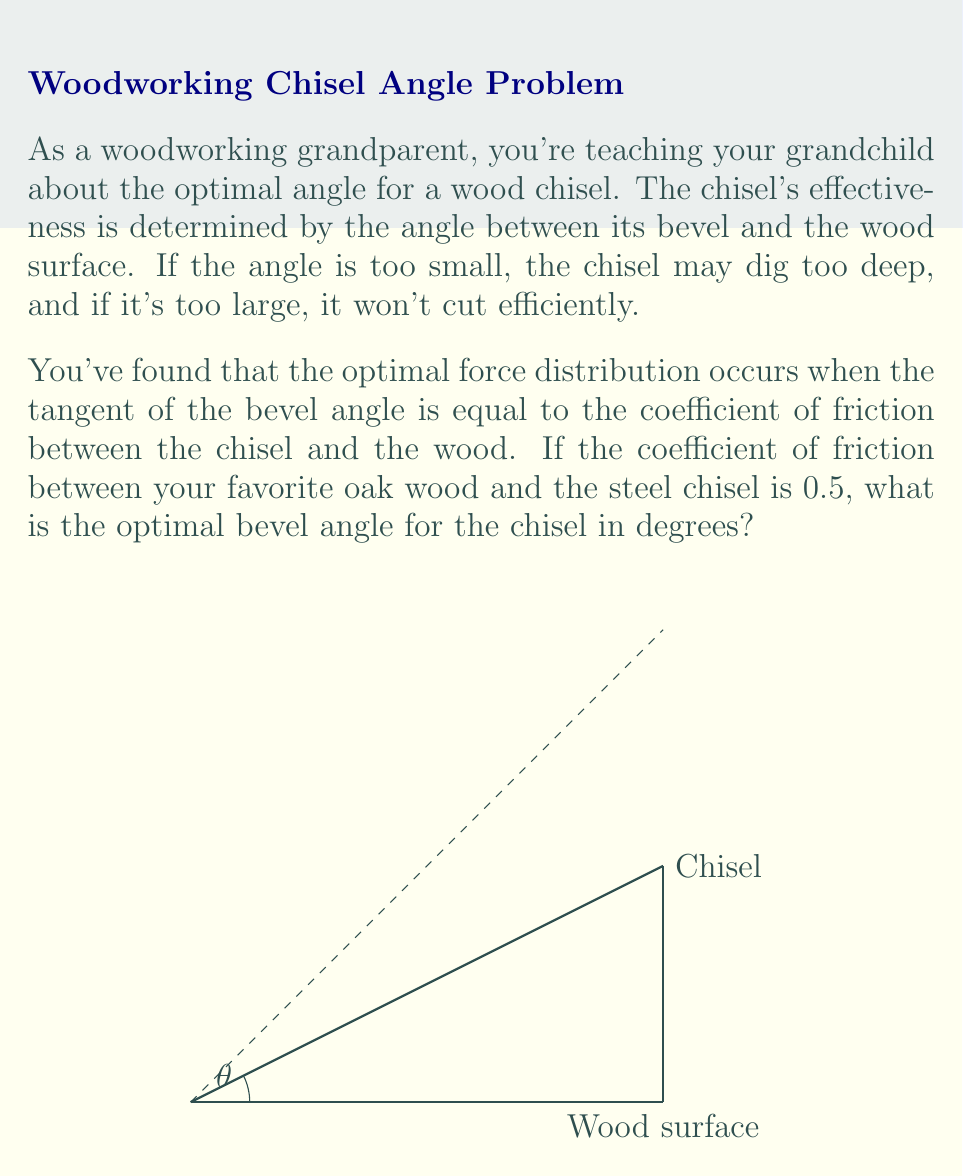Can you answer this question? Let's approach this step-by-step:

1) We're given that the optimal angle occurs when:

   $$\tan(\theta) = \mu$$

   where $\theta$ is the bevel angle and $\mu$ is the coefficient of friction.

2) We're given that $\mu = 0.5$ for oak wood and the steel chisel.

3) Substituting this into our equation:

   $$\tan(\theta) = 0.5$$

4) To find $\theta$, we need to take the inverse tangent (arctangent) of both sides:

   $$\theta = \arctan(0.5)$$

5) Using a calculator or mathematical software, we can compute this value:

   $$\theta \approx 0.4636476 \text{ radians}$$

6) However, we need to convert this to degrees. We can do this by multiplying by $\frac{180}{\pi}$:

   $$\theta \approx 0.4636476 \times \frac{180}{\pi} \approx 26.57^\circ$$

7) Rounding to two decimal places for practicality in woodworking:

   $$\theta \approx 26.57^\circ$$
Answer: $26.57^\circ$ 